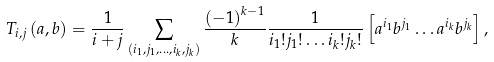Convert formula to latex. <formula><loc_0><loc_0><loc_500><loc_500>T _ { i , j } \left ( a , b \right ) = \frac { 1 } { i + j } \sum _ { \left ( i _ { 1 } , j _ { 1 } , \dots , i _ { k } , j _ { k } \right ) } \frac { \left ( - 1 \right ) ^ { k - 1 } } { k } \frac { 1 } { i _ { 1 } ! j _ { 1 } ! \dots i _ { k } ! j _ { k } ! } \left [ a ^ { i _ { 1 } } b ^ { j _ { 1 } } \dots a ^ { i _ { k } } b ^ { j _ { k } } \right ] ,</formula> 